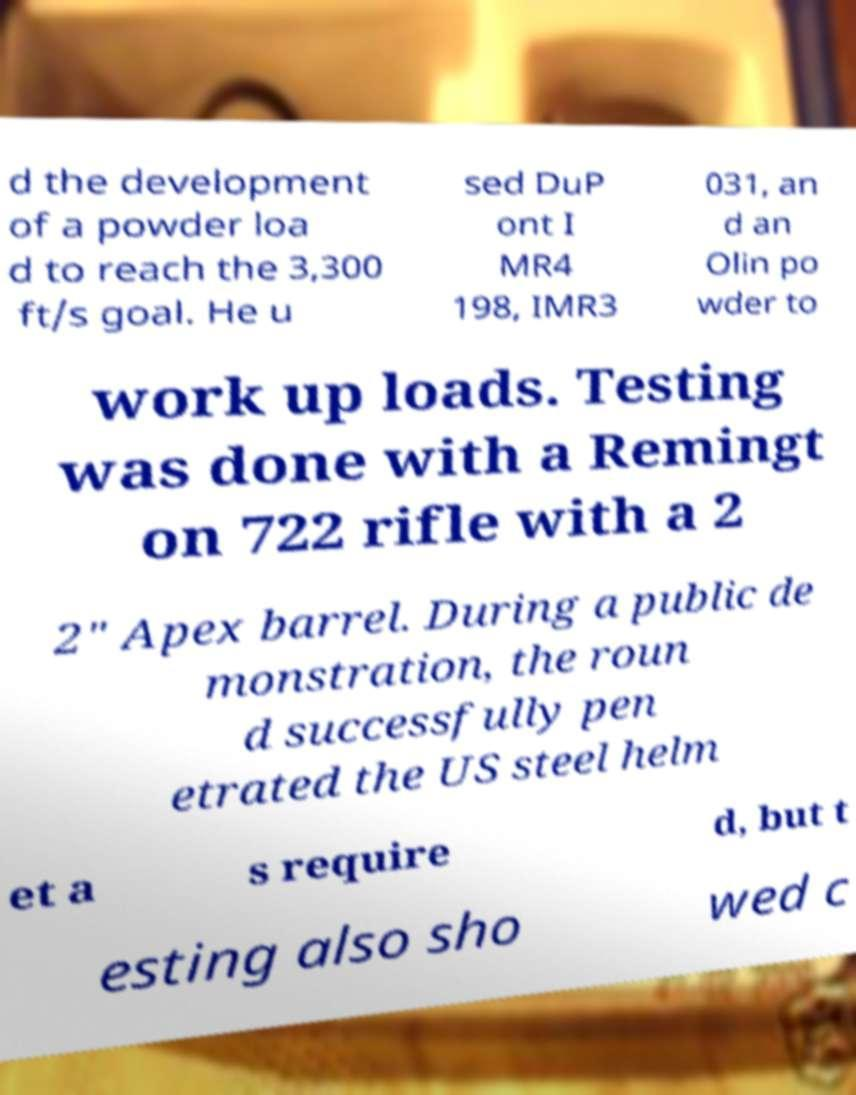What messages or text are displayed in this image? I need them in a readable, typed format. d the development of a powder loa d to reach the 3,300 ft/s goal. He u sed DuP ont I MR4 198, IMR3 031, an d an Olin po wder to work up loads. Testing was done with a Remingt on 722 rifle with a 2 2" Apex barrel. During a public de monstration, the roun d successfully pen etrated the US steel helm et a s require d, but t esting also sho wed c 